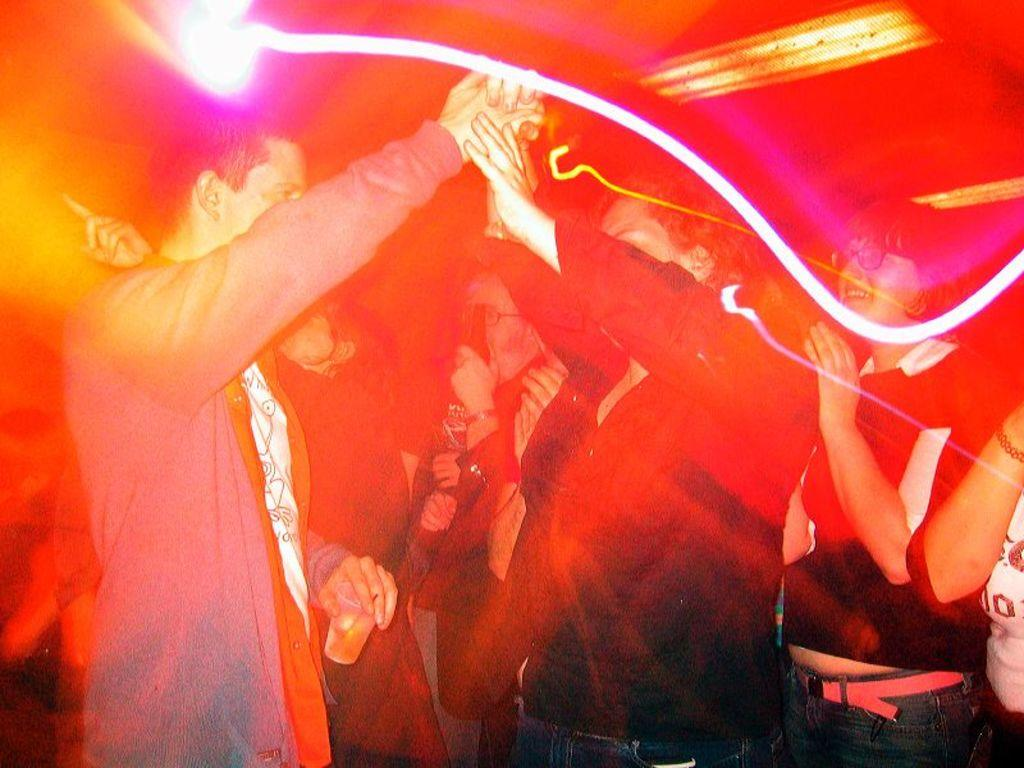Who is present in the image? There are people in the image. What is the man holding in his hand? The man is holding a glass in his hand. Can you describe the overall appearance of the image? The image is colorful. What type of rod can be seen in the image? There is no rod present in the image. How does the man blow into the glass in the image? The man is not blowing into the glass in the image; he is simply holding it. 